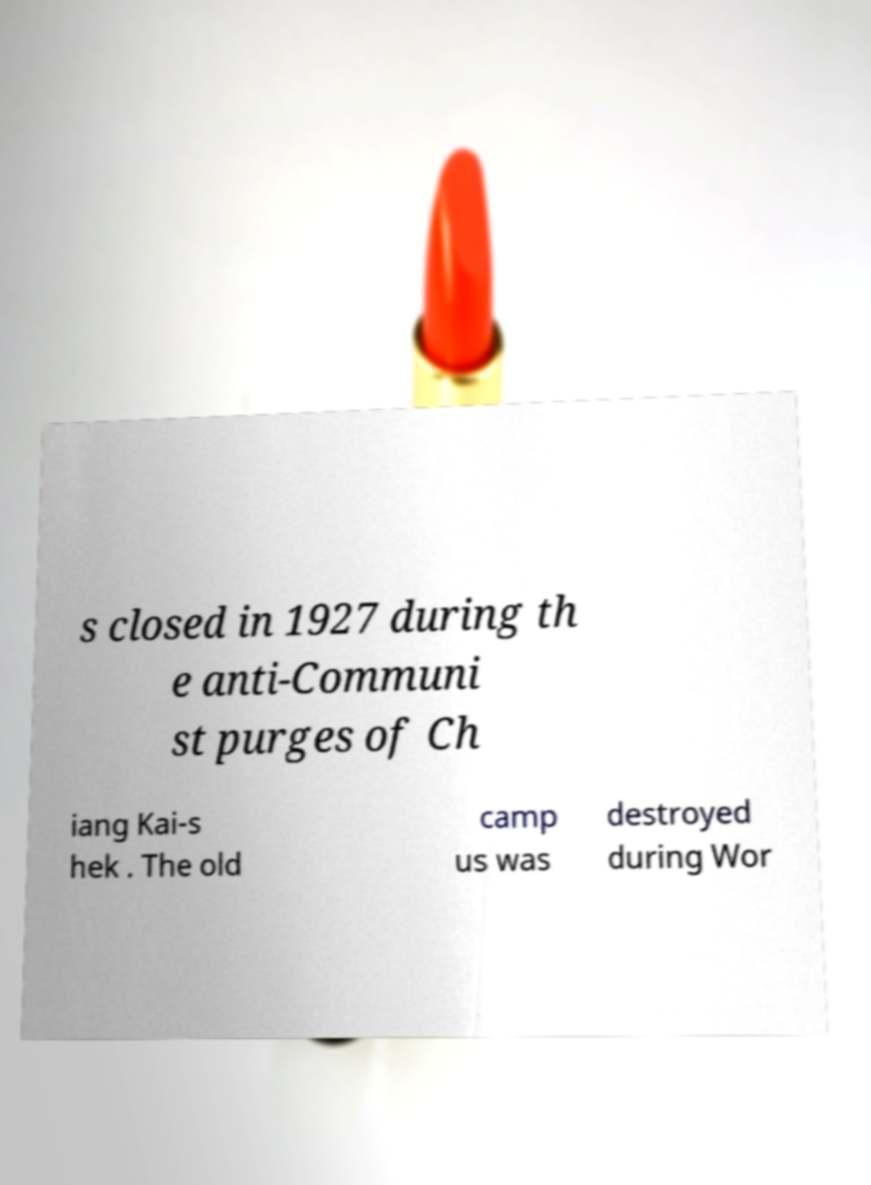Can you accurately transcribe the text from the provided image for me? s closed in 1927 during th e anti-Communi st purges of Ch iang Kai-s hek . The old camp us was destroyed during Wor 